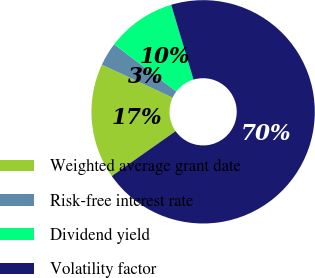Convert chart. <chart><loc_0><loc_0><loc_500><loc_500><pie_chart><fcel>Weighted average grant date<fcel>Risk-free interest rate<fcel>Dividend yield<fcel>Volatility factor<nl><fcel>16.69%<fcel>3.4%<fcel>10.05%<fcel>69.86%<nl></chart> 